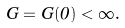Convert formula to latex. <formula><loc_0><loc_0><loc_500><loc_500>G = G ( 0 ) < \infty .</formula> 